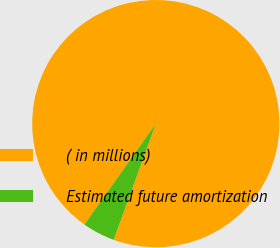Convert chart to OTSL. <chart><loc_0><loc_0><loc_500><loc_500><pie_chart><fcel>( in millions)<fcel>Estimated future amortization<nl><fcel>95.73%<fcel>4.27%<nl></chart> 